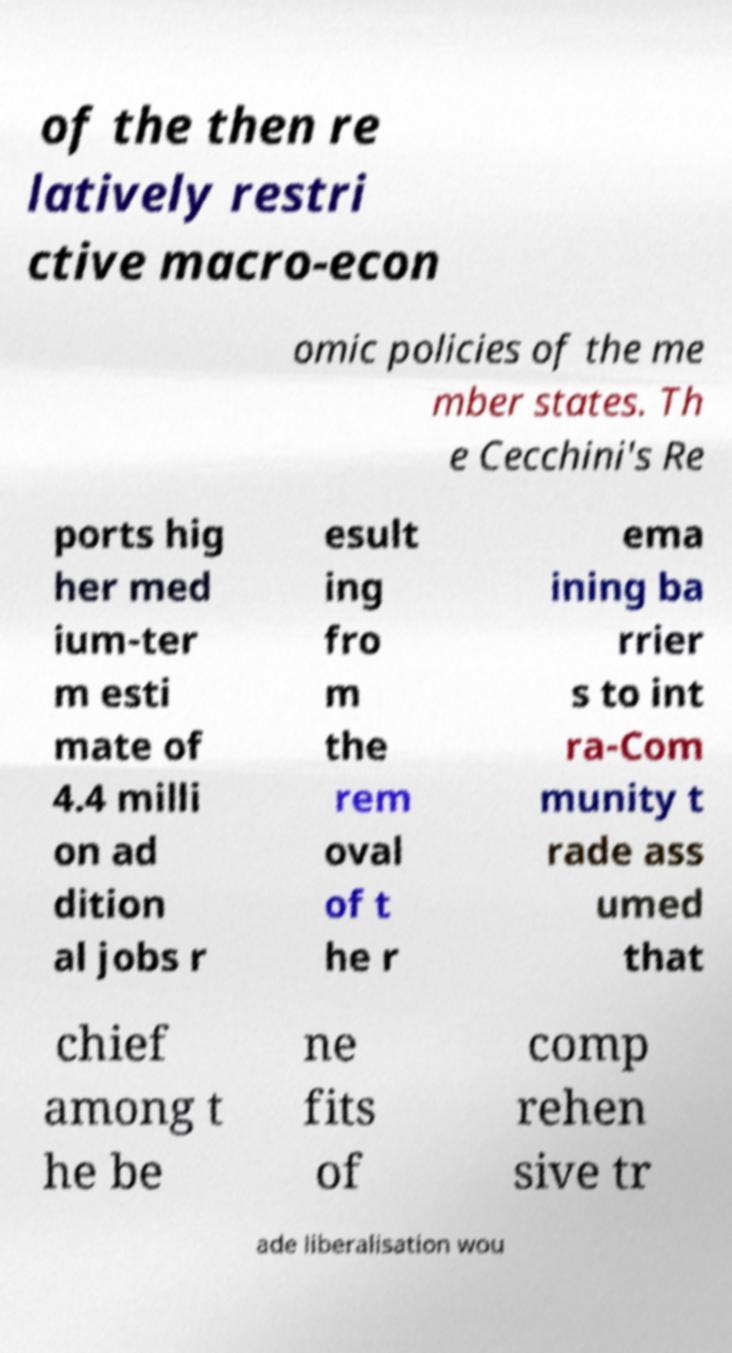Can you read and provide the text displayed in the image?This photo seems to have some interesting text. Can you extract and type it out for me? of the then re latively restri ctive macro-econ omic policies of the me mber states. Th e Cecchini's Re ports hig her med ium-ter m esti mate of 4.4 milli on ad dition al jobs r esult ing fro m the rem oval of t he r ema ining ba rrier s to int ra-Com munity t rade ass umed that chief among t he be ne fits of comp rehen sive tr ade liberalisation wou 